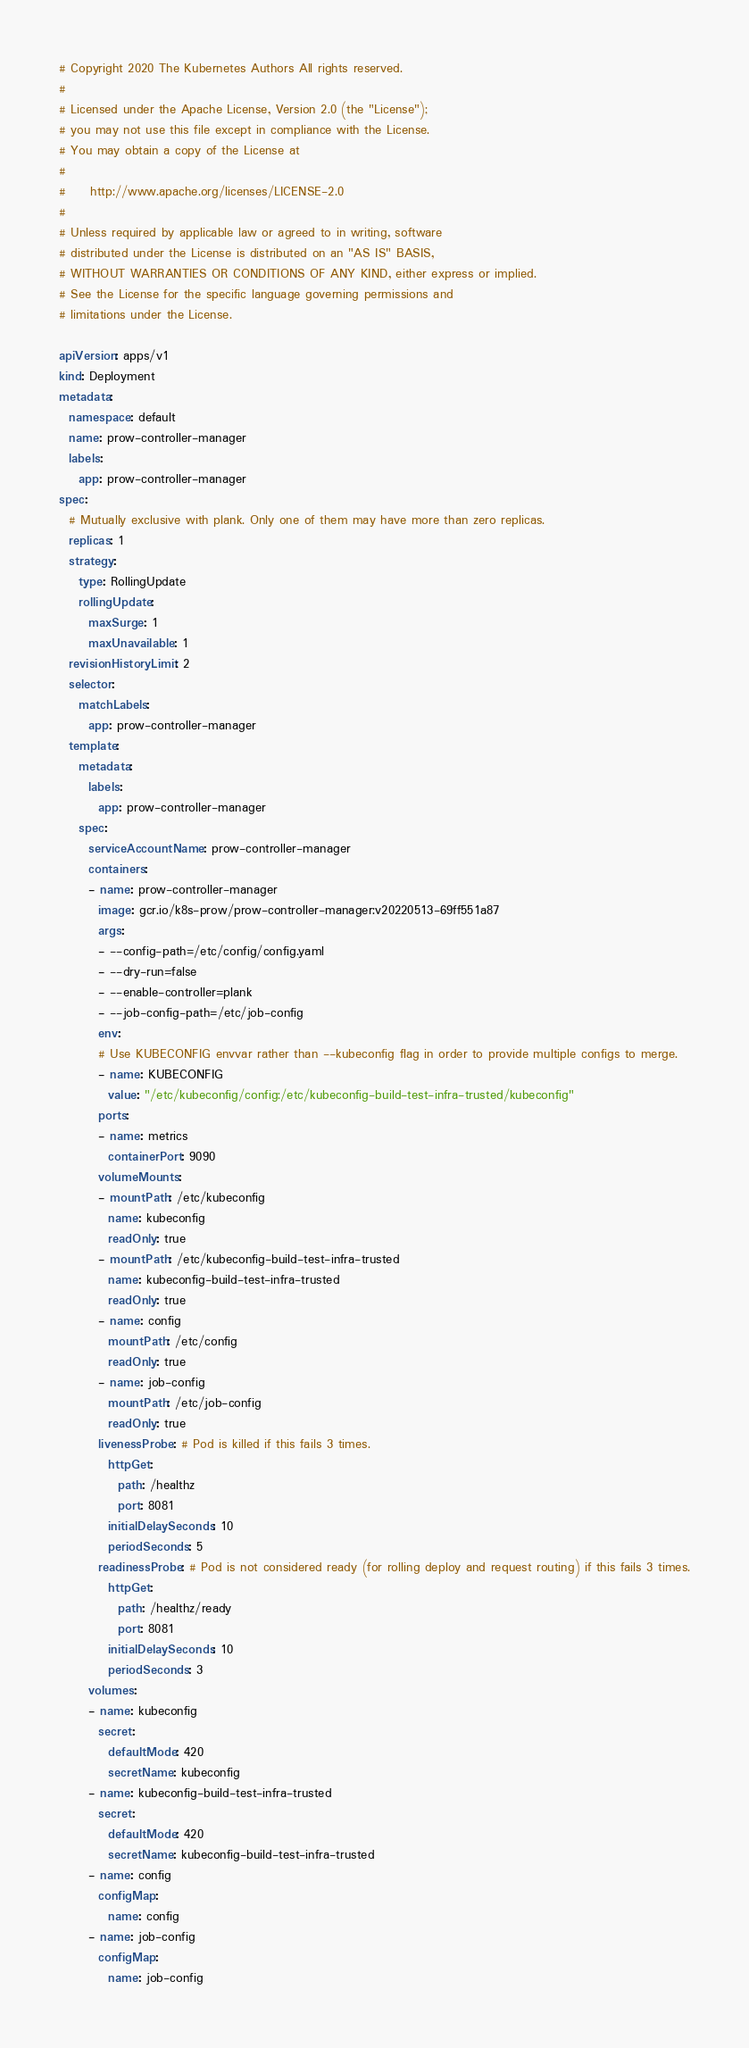<code> <loc_0><loc_0><loc_500><loc_500><_YAML_># Copyright 2020 The Kubernetes Authors All rights reserved.
#
# Licensed under the Apache License, Version 2.0 (the "License");
# you may not use this file except in compliance with the License.
# You may obtain a copy of the License at
#
#     http://www.apache.org/licenses/LICENSE-2.0
#
# Unless required by applicable law or agreed to in writing, software
# distributed under the License is distributed on an "AS IS" BASIS,
# WITHOUT WARRANTIES OR CONDITIONS OF ANY KIND, either express or implied.
# See the License for the specific language governing permissions and
# limitations under the License.

apiVersion: apps/v1
kind: Deployment
metadata:
  namespace: default
  name: prow-controller-manager
  labels:
    app: prow-controller-manager
spec:
  # Mutually exclusive with plank. Only one of them may have more than zero replicas.
  replicas: 1
  strategy:
    type: RollingUpdate
    rollingUpdate:
      maxSurge: 1
      maxUnavailable: 1
  revisionHistoryLimit: 2
  selector:
    matchLabels:
      app: prow-controller-manager
  template:
    metadata:
      labels:
        app: prow-controller-manager
    spec:
      serviceAccountName: prow-controller-manager
      containers:
      - name: prow-controller-manager
        image: gcr.io/k8s-prow/prow-controller-manager:v20220513-69ff551a87
        args:
        - --config-path=/etc/config/config.yaml
        - --dry-run=false
        - --enable-controller=plank
        - --job-config-path=/etc/job-config
        env:
        # Use KUBECONFIG envvar rather than --kubeconfig flag in order to provide multiple configs to merge.
        - name: KUBECONFIG
          value: "/etc/kubeconfig/config:/etc/kubeconfig-build-test-infra-trusted/kubeconfig"
        ports:
        - name: metrics
          containerPort: 9090
        volumeMounts:
        - mountPath: /etc/kubeconfig
          name: kubeconfig
          readOnly: true
        - mountPath: /etc/kubeconfig-build-test-infra-trusted
          name: kubeconfig-build-test-infra-trusted
          readOnly: true
        - name: config
          mountPath: /etc/config
          readOnly: true
        - name: job-config
          mountPath: /etc/job-config
          readOnly: true
        livenessProbe: # Pod is killed if this fails 3 times.
          httpGet:
            path: /healthz
            port: 8081
          initialDelaySeconds: 10
          periodSeconds: 5
        readinessProbe: # Pod is not considered ready (for rolling deploy and request routing) if this fails 3 times.
          httpGet:
            path: /healthz/ready
            port: 8081
          initialDelaySeconds: 10
          periodSeconds: 3
      volumes:
      - name: kubeconfig
        secret:
          defaultMode: 420
          secretName: kubeconfig
      - name: kubeconfig-build-test-infra-trusted
        secret:
          defaultMode: 420
          secretName: kubeconfig-build-test-infra-trusted
      - name: config
        configMap:
          name: config
      - name: job-config
        configMap:
          name: job-config
</code> 